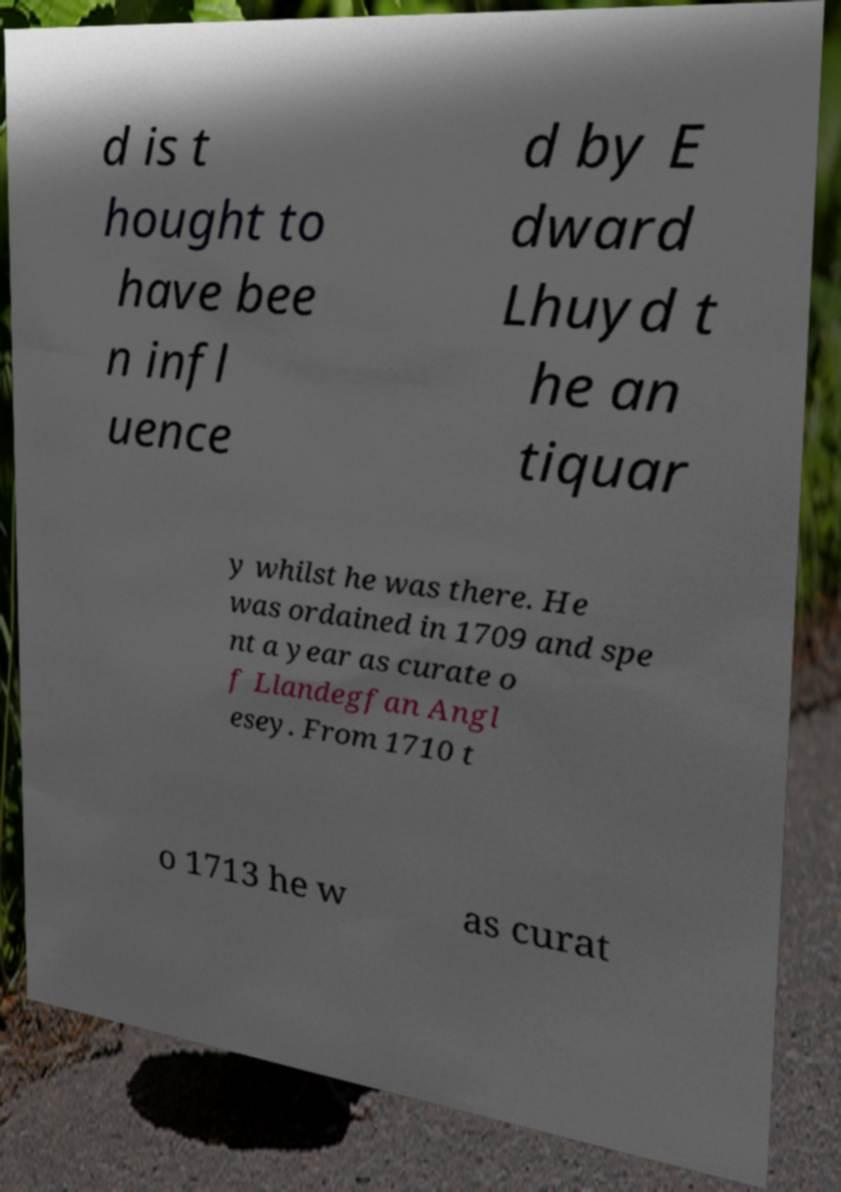There's text embedded in this image that I need extracted. Can you transcribe it verbatim? d is t hought to have bee n infl uence d by E dward Lhuyd t he an tiquar y whilst he was there. He was ordained in 1709 and spe nt a year as curate o f Llandegfan Angl esey. From 1710 t o 1713 he w as curat 